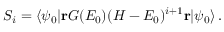<formula> <loc_0><loc_0><loc_500><loc_500>S _ { i } = \langle \psi _ { 0 } | r G ( E _ { 0 } ) ( H - E _ { 0 } ) ^ { i + 1 } r | \psi _ { 0 } \rangle \, .</formula> 